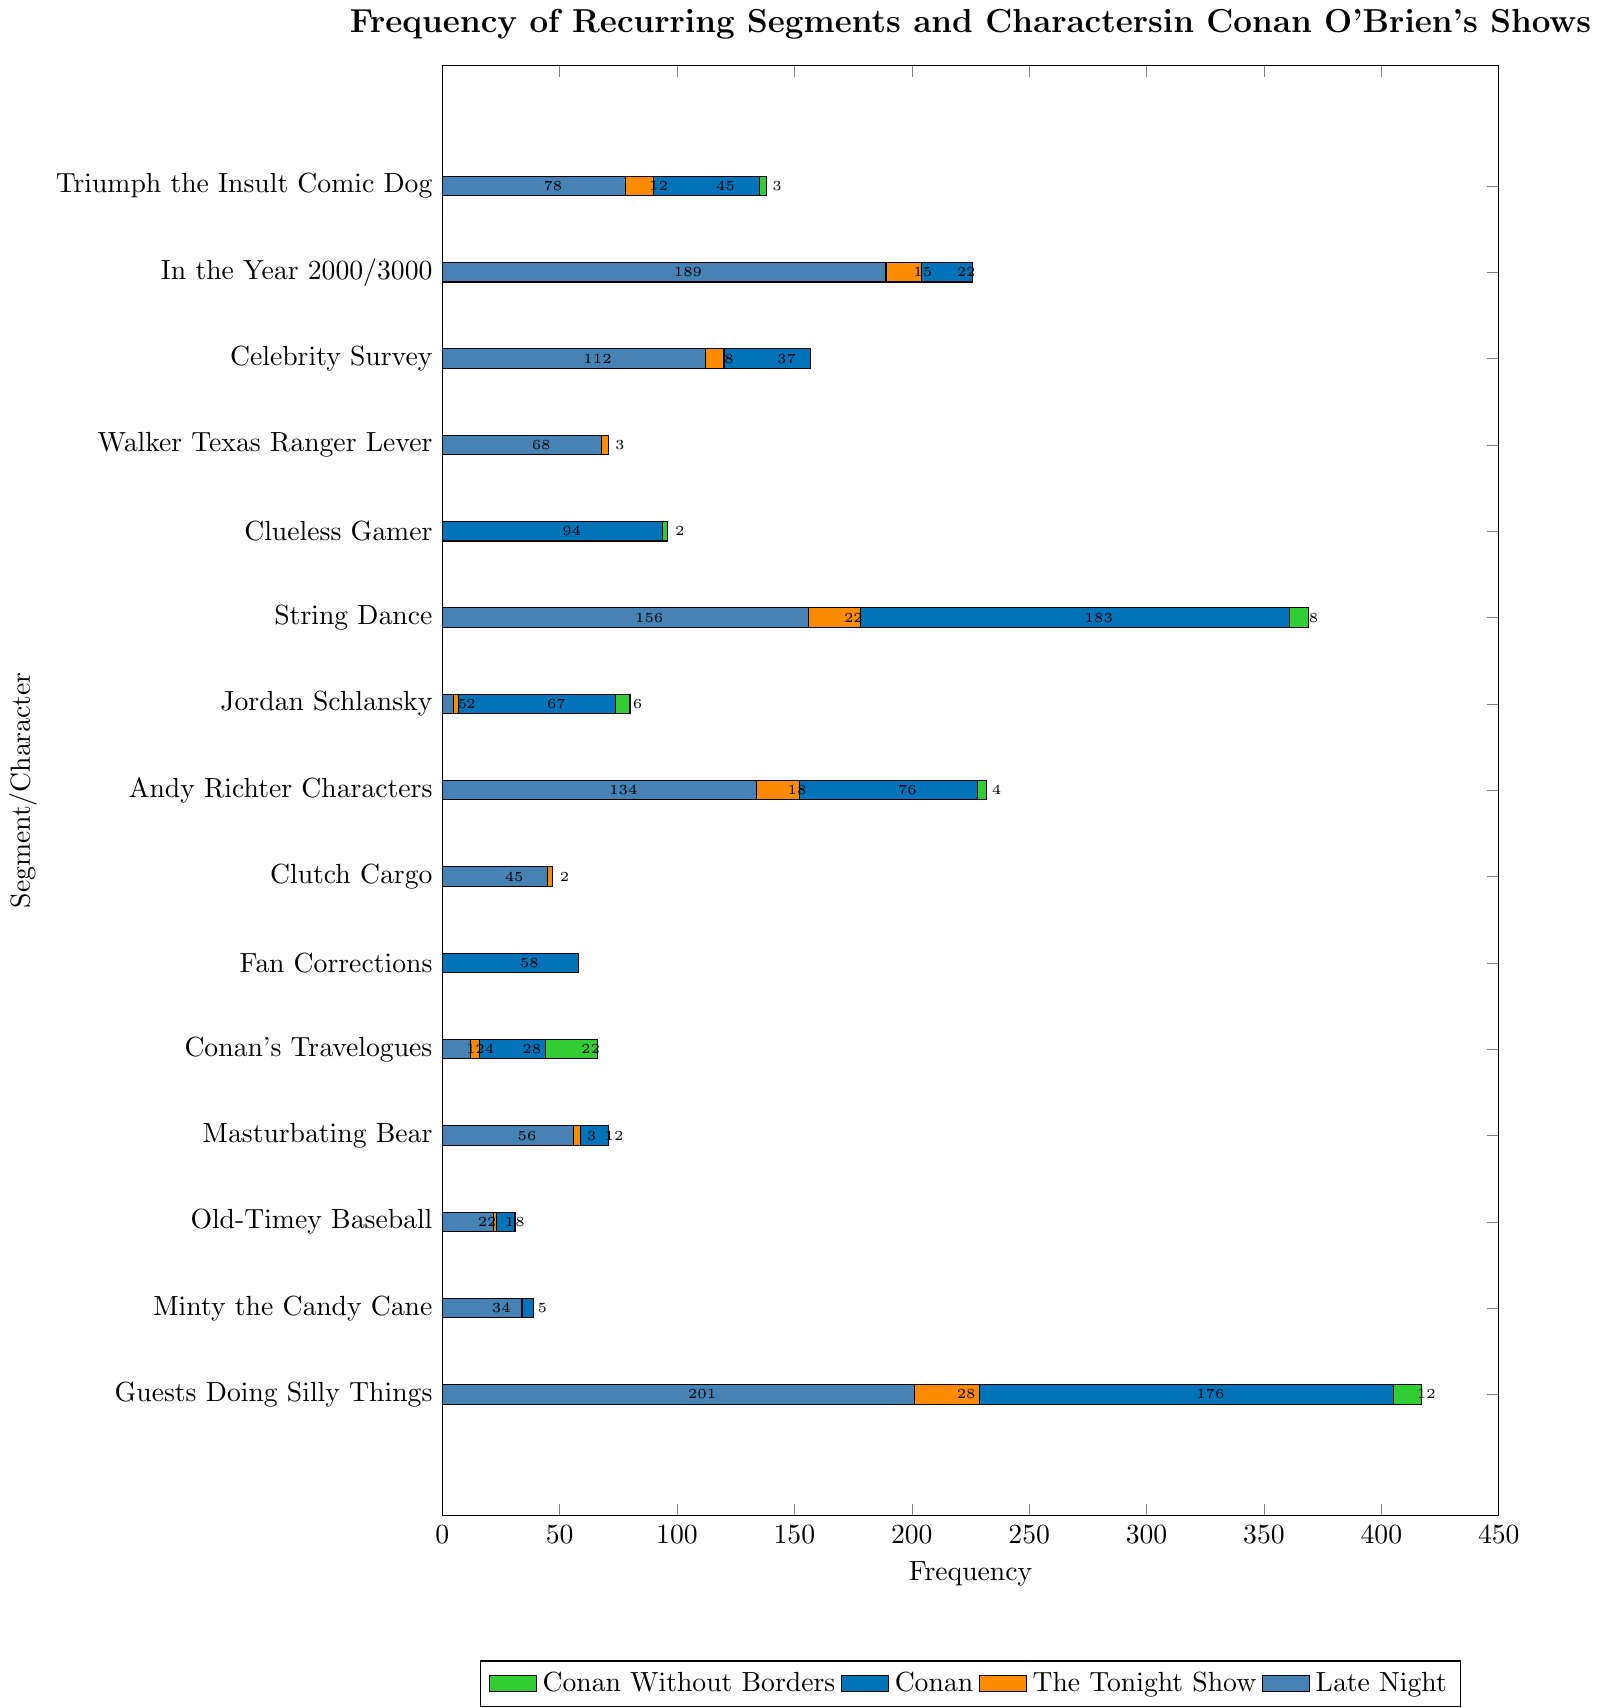Who appears more frequently in "Conan" shows, Andy Richter Characters or Jordan Schlansky? To compare, look at the length of the bars for "Conan" shows within the "Andy Richter Characters" and "Jordan Schlansky" rows. "Andy Richter Characters" has a frequency of 76, while "Jordan Schlansky" has a frequency of 67.
Answer: Andy Richter Characters Which segment/character has the highest total frequency across all shows? To find this, sum the frequencies across all shows for each segment/character. "Guests Doing Silly Things" has 201 (Late Night) + 28 (The Tonight Show) + 176 (Conan) + 12 (Conan Without Borders) = 417, which is higher than any other segment/character.
Answer: Guests Doing Silly Things Which show features the "Triumph the Insult Comic Dog" segment most frequently? Look at the lengths of the bars for "Triumph the Insult Comic Dog" across all shows. The bar for "Late Night" is the longest, with a frequency of 78.
Answer: Late Night Compare the total frequency of "Clueless Gamer" and "Triumph the Insult Comic Dog" across all shows. Which one is higher and by how much? Calculate the total frequency for both segments across all shows. "Clueless Gamer": 0 (Late Night) + 0 (The Tonight Show) + 94 (Conan) + 2 (Conan Without Borders) = 96. "Triumph the Insult Comic Dog": 78 (Late Night) + 12 (The Tonight Show) + 45 (Conan) + 3 (Conan Without Borders) = 138. The difference is 138 - 96 = 42.
Answer: Triumph the Insult Comic Dog by 42 What is the average frequency of "Masturbating Bear" appearances across all shows? Calculate the total appearances of "Masturbating Bear" across all shows and divide by the number of shows. Total = 56 (Late Night) + 3 (The Tonight Show) + 12 (Conan) + 0 (Conan Without Borders). Average = (56 + 3 + 12 + 0) / 4 = 71 / 4 = 17.75.
Answer: 17.75 Which segment/character has more appearances in "Conan Without Borders" than in "The Tonight Show"? Compare the values for "The Tonight Show" and "Conan Without Borders" for each segment/character. "Conan's Travelogues" has 22 (Conan Without Borders) which is greater than 4 (The Tonight Show). Similarly, "Jordan Schlansky" has 6 (Conan Without Borders) compared to 2 (The Tonight Show).
Answer: Conan's Travelogues, Jordan Schlansky Which show has the least appearances of "Walker Texas Ranger Lever" and what is its frequency in that show? Look at the lengths of the bars for "Walker Texas Ranger Lever" across all shows. The bar for "The Tonight Show" is the shortest, with a frequency of 3.
Answer: The Tonight Show, 3 How many total segments/characters had a frequency of zero in "Conan Without Borders"? Count the segments/characters with zero frequency in "Conan Without Borders". The segments/characters with zero are: "In the Year 2000/3000", "Celebrity Survey", "Walker Texas Ranger Lever", "Clutch Cargo", "Fan Corrections", "Masturbating Bear", "Old-Timey Baseball", "Minty the Candy Cane". There are 8 in total.
Answer: 8 